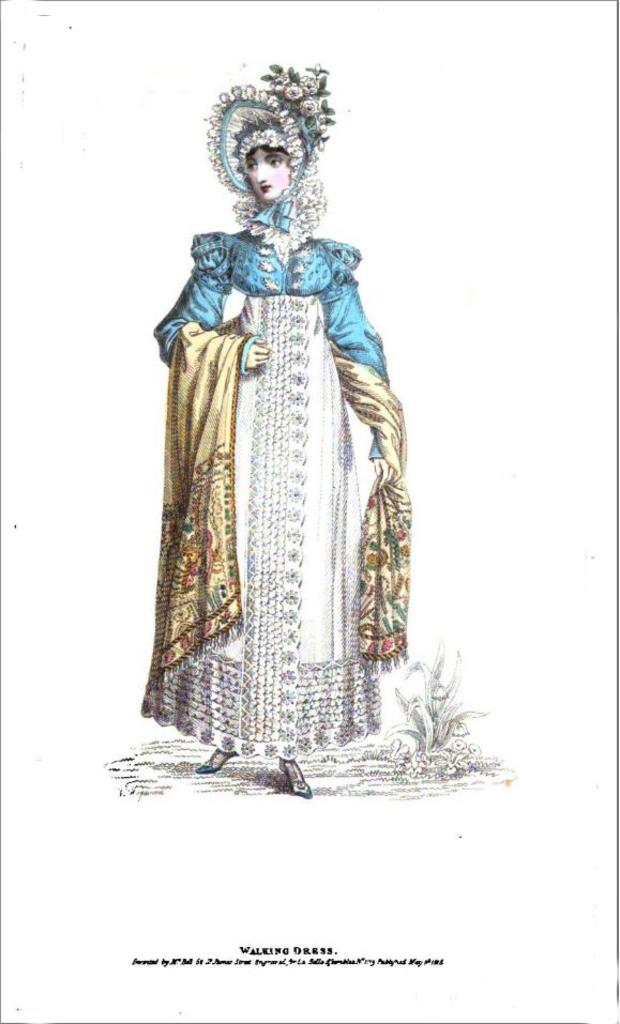What is the main subject of the image? There is a painting in the image. Can you describe any other elements in the image? Yes, there is a person standing in the image, a plant, and text. What is the color of the background in the image? The background of the image is white in color. How many stamps are visible on the painting in the image? There are no stamps visible on the painting in the image. Can you describe the jellyfish swimming in the background of the image? There are no jellyfish present in the image; the background is white. 